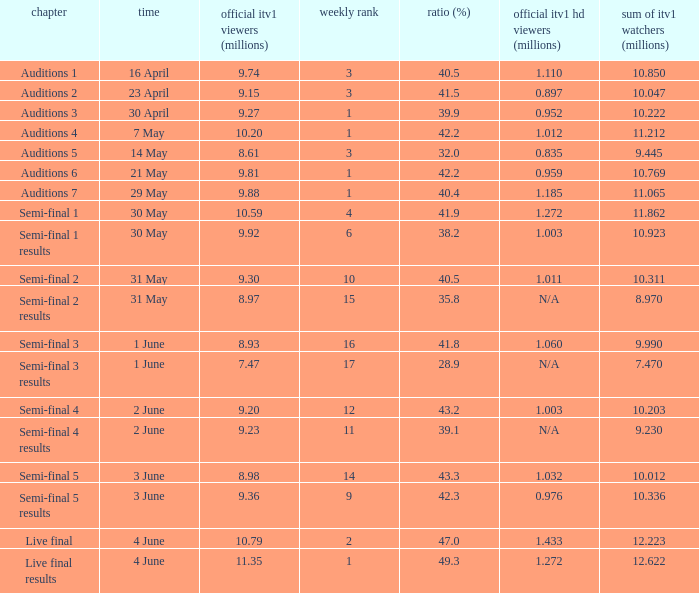What was the total ITV1 viewers in millions for the episode with a share (%) of 28.9?  7.47. 